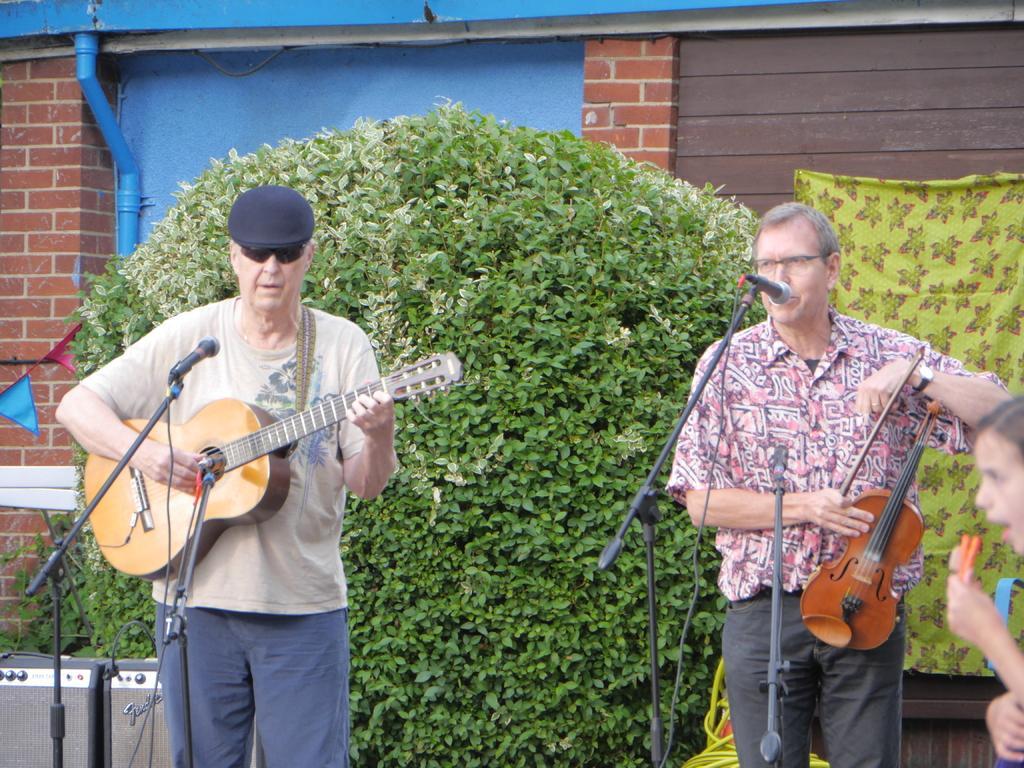Please provide a concise description of this image. In this image I can see few people playing musical instruments. I can also see mice in front of them. In the background I can see a plant and a red color of building. 